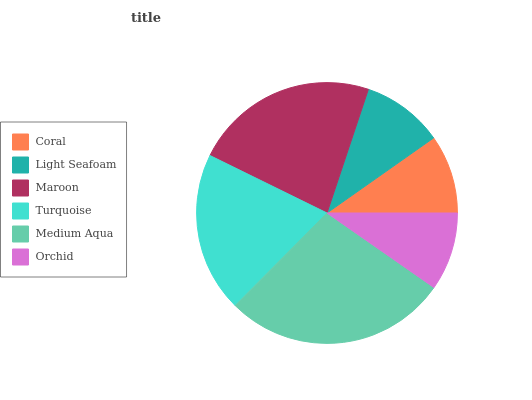Is Orchid the minimum?
Answer yes or no. Yes. Is Medium Aqua the maximum?
Answer yes or no. Yes. Is Light Seafoam the minimum?
Answer yes or no. No. Is Light Seafoam the maximum?
Answer yes or no. No. Is Light Seafoam greater than Coral?
Answer yes or no. Yes. Is Coral less than Light Seafoam?
Answer yes or no. Yes. Is Coral greater than Light Seafoam?
Answer yes or no. No. Is Light Seafoam less than Coral?
Answer yes or no. No. Is Turquoise the high median?
Answer yes or no. Yes. Is Light Seafoam the low median?
Answer yes or no. Yes. Is Orchid the high median?
Answer yes or no. No. Is Turquoise the low median?
Answer yes or no. No. 